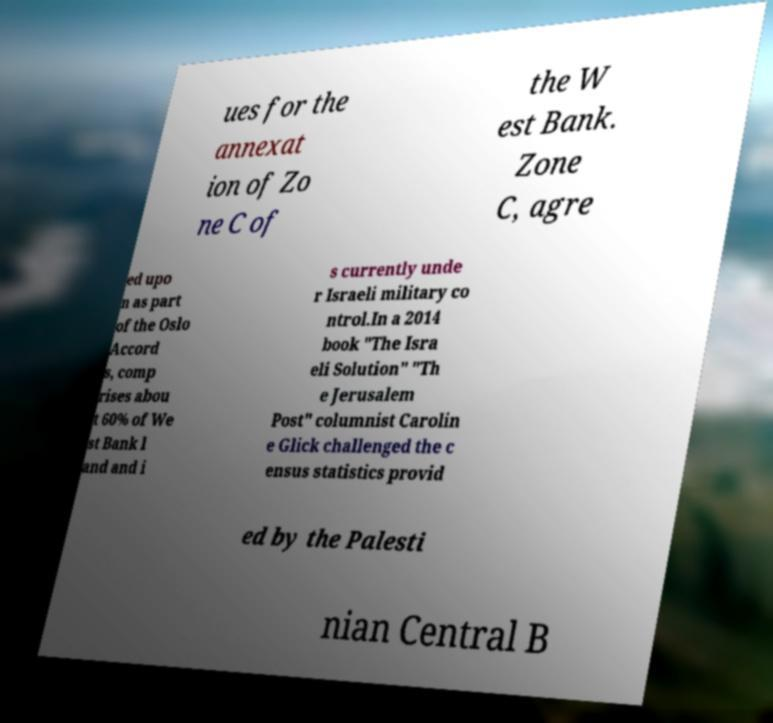What messages or text are displayed in this image? I need them in a readable, typed format. ues for the annexat ion of Zo ne C of the W est Bank. Zone C, agre ed upo n as part of the Oslo Accord s, comp rises abou t 60% of We st Bank l and and i s currently unde r Israeli military co ntrol.In a 2014 book "The Isra eli Solution" "Th e Jerusalem Post" columnist Carolin e Glick challenged the c ensus statistics provid ed by the Palesti nian Central B 